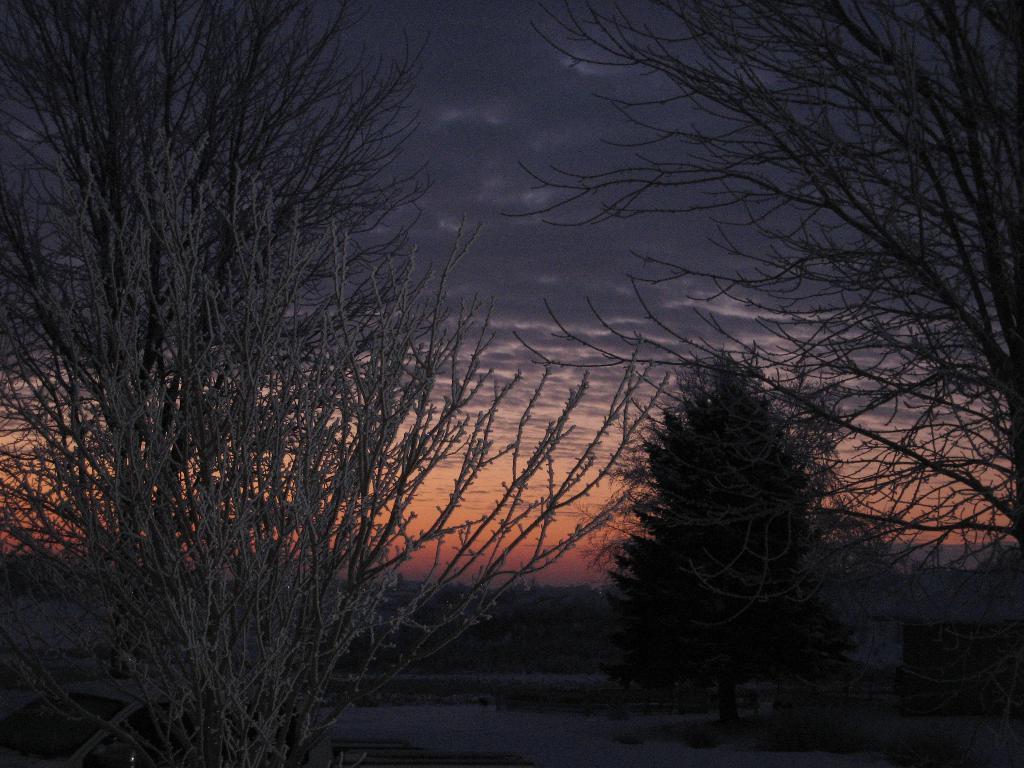In one or two sentences, can you explain what this image depicts? In this picture there are trees in the image, which are covered with snow and there is snow in the background area of the image, there is sky at the top side of the image. 